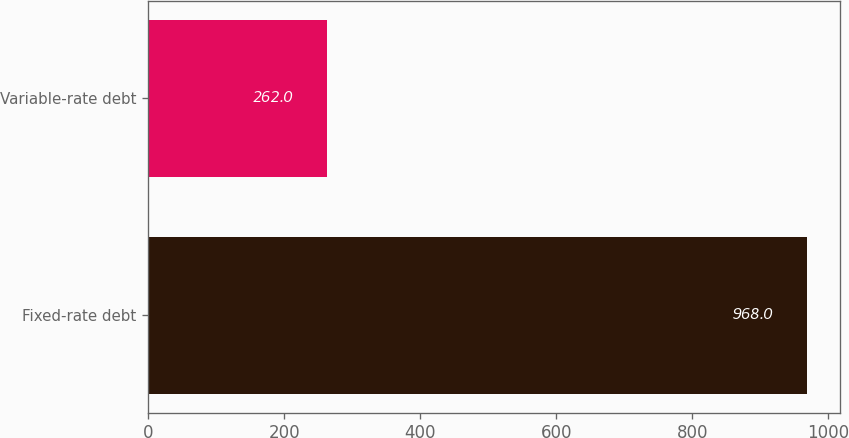<chart> <loc_0><loc_0><loc_500><loc_500><bar_chart><fcel>Fixed-rate debt<fcel>Variable-rate debt<nl><fcel>968<fcel>262<nl></chart> 